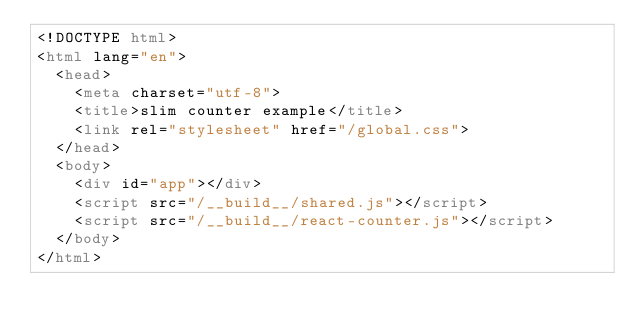Convert code to text. <code><loc_0><loc_0><loc_500><loc_500><_HTML_><!DOCTYPE html>
<html lang="en">
  <head>
    <meta charset="utf-8">
    <title>slim counter example</title>
    <link rel="stylesheet" href="/global.css">
  </head>
  <body>
    <div id="app"></div>
    <script src="/__build__/shared.js"></script>
    <script src="/__build__/react-counter.js"></script>
  </body>
</html>
</code> 